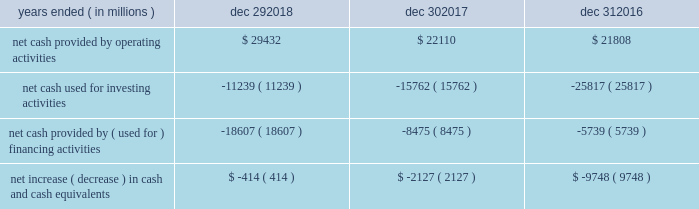Sources and uses of cash ( in millions ) in summary , our cash flows for each period were as follows : years ended ( in millions ) dec 29 , dec 30 , dec 31 .
Md&a consolidated results and analysis 40 .
What was the percentage change in net cash provided by operating activities between 2016 and 2017? 
Computations: ((22110 - 21808) / 21808)
Answer: 0.01385. 